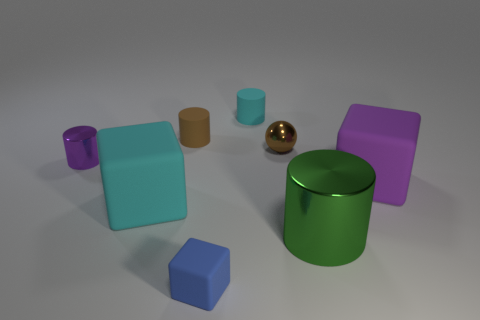What number of other objects are there of the same color as the tiny metal sphere?
Offer a very short reply. 1. Is the number of purple matte things in front of the green metallic object greater than the number of purple objects?
Offer a very short reply. No. There is a big rubber block that is in front of the rubber block behind the big object to the left of the blue thing; what is its color?
Your response must be concise. Cyan. Do the tiny block and the small cyan cylinder have the same material?
Your response must be concise. Yes. Are there any other cyan matte cylinders of the same size as the cyan cylinder?
Your response must be concise. No. There is a blue cube that is the same size as the purple cylinder; what is its material?
Offer a terse response. Rubber. Are there the same number of small red things and small purple metal things?
Offer a terse response. No. Is there a large brown rubber thing that has the same shape as the tiny cyan rubber object?
Offer a very short reply. No. What material is the tiny object that is the same color as the tiny metal ball?
Provide a succinct answer. Rubber. There is a purple thing right of the small brown shiny sphere; what shape is it?
Your response must be concise. Cube. 